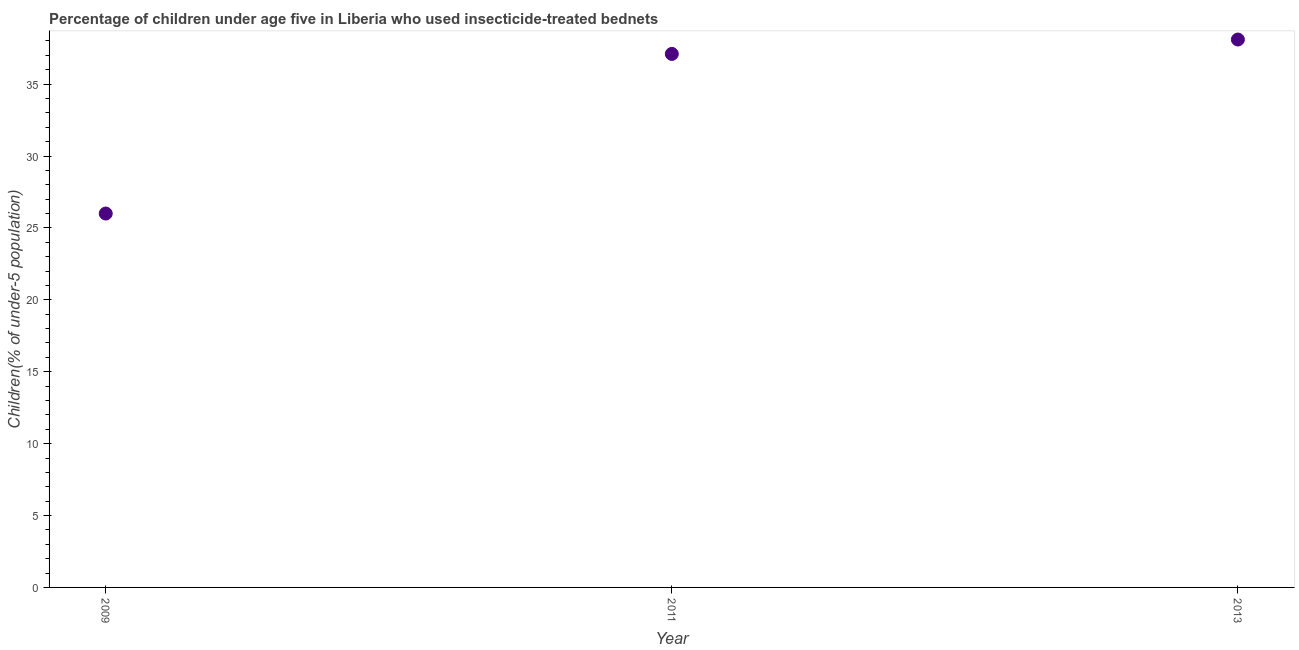Across all years, what is the maximum percentage of children who use of insecticide-treated bed nets?
Offer a terse response. 38.1. Across all years, what is the minimum percentage of children who use of insecticide-treated bed nets?
Keep it short and to the point. 26. In which year was the percentage of children who use of insecticide-treated bed nets maximum?
Your response must be concise. 2013. In which year was the percentage of children who use of insecticide-treated bed nets minimum?
Give a very brief answer. 2009. What is the sum of the percentage of children who use of insecticide-treated bed nets?
Your answer should be compact. 101.2. What is the difference between the percentage of children who use of insecticide-treated bed nets in 2009 and 2013?
Your answer should be compact. -12.1. What is the average percentage of children who use of insecticide-treated bed nets per year?
Offer a very short reply. 33.73. What is the median percentage of children who use of insecticide-treated bed nets?
Your response must be concise. 37.1. What is the ratio of the percentage of children who use of insecticide-treated bed nets in 2011 to that in 2013?
Provide a short and direct response. 0.97. Is the difference between the percentage of children who use of insecticide-treated bed nets in 2009 and 2013 greater than the difference between any two years?
Provide a short and direct response. Yes. What is the difference between the highest and the second highest percentage of children who use of insecticide-treated bed nets?
Keep it short and to the point. 1. What is the difference between the highest and the lowest percentage of children who use of insecticide-treated bed nets?
Offer a terse response. 12.1. In how many years, is the percentage of children who use of insecticide-treated bed nets greater than the average percentage of children who use of insecticide-treated bed nets taken over all years?
Make the answer very short. 2. Does the percentage of children who use of insecticide-treated bed nets monotonically increase over the years?
Give a very brief answer. Yes. How many years are there in the graph?
Offer a terse response. 3. Are the values on the major ticks of Y-axis written in scientific E-notation?
Offer a very short reply. No. Does the graph contain grids?
Your answer should be very brief. No. What is the title of the graph?
Make the answer very short. Percentage of children under age five in Liberia who used insecticide-treated bednets. What is the label or title of the Y-axis?
Your response must be concise. Children(% of under-5 population). What is the Children(% of under-5 population) in 2011?
Provide a succinct answer. 37.1. What is the Children(% of under-5 population) in 2013?
Make the answer very short. 38.1. What is the difference between the Children(% of under-5 population) in 2009 and 2013?
Provide a short and direct response. -12.1. What is the ratio of the Children(% of under-5 population) in 2009 to that in 2011?
Ensure brevity in your answer.  0.7. What is the ratio of the Children(% of under-5 population) in 2009 to that in 2013?
Keep it short and to the point. 0.68. 